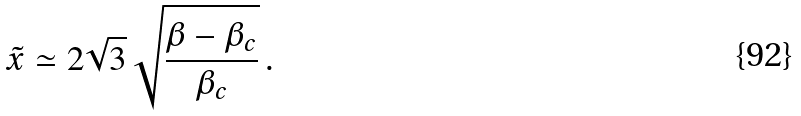Convert formula to latex. <formula><loc_0><loc_0><loc_500><loc_500>\tilde { x } \simeq 2 \sqrt { 3 } \, \sqrt { \frac { \beta - \beta _ { c } } { \beta _ { c } } } \, .</formula> 